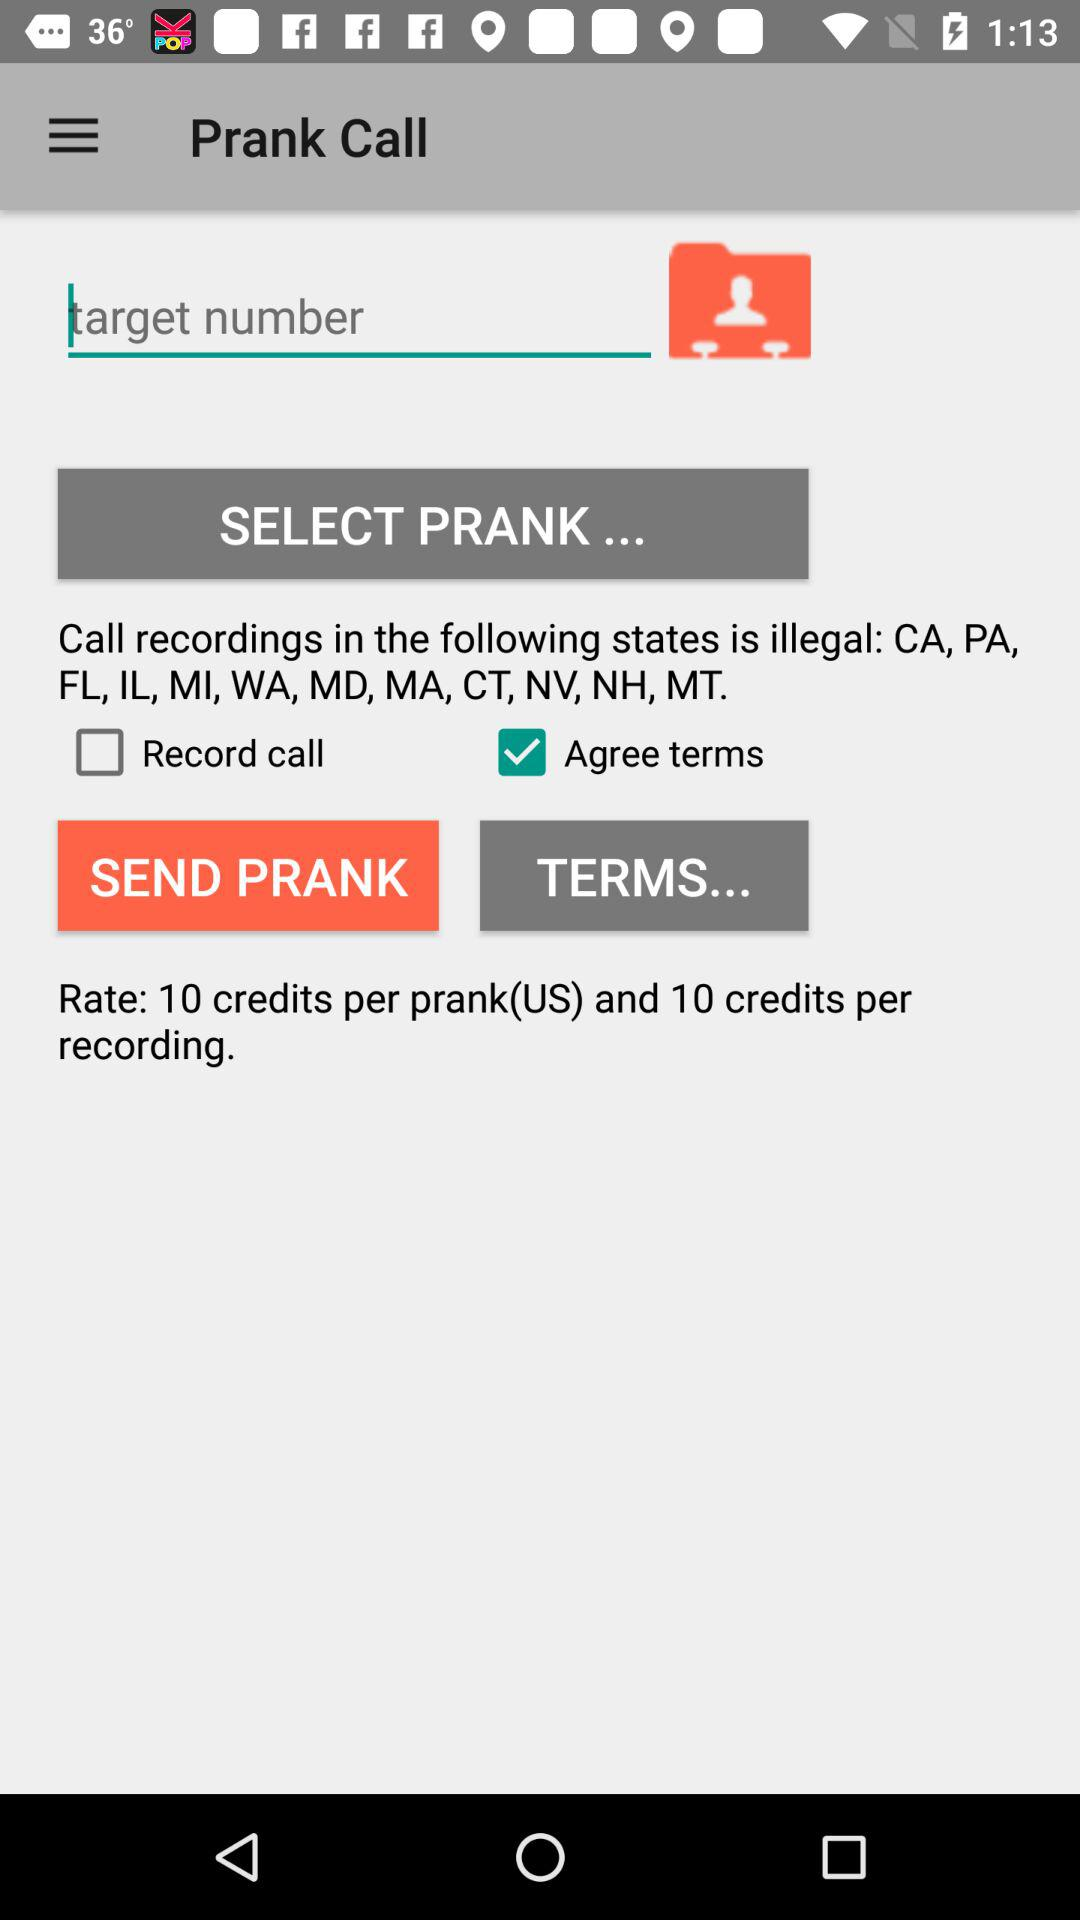How many credits are required for a prank call?
Answer the question using a single word or phrase. 10 